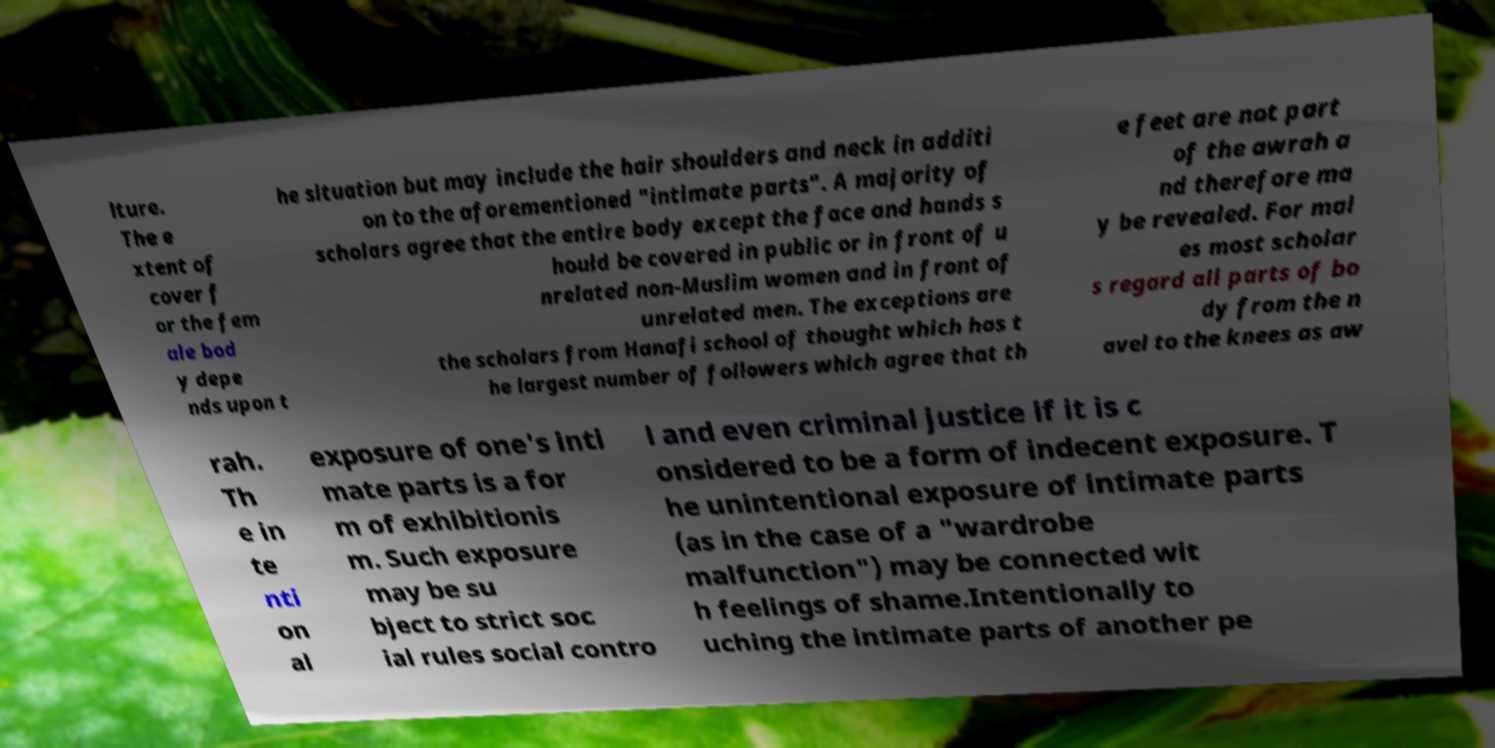Please read and relay the text visible in this image. What does it say? lture. The e xtent of cover f or the fem ale bod y depe nds upon t he situation but may include the hair shoulders and neck in additi on to the aforementioned "intimate parts". A majority of scholars agree that the entire body except the face and hands s hould be covered in public or in front of u nrelated non-Muslim women and in front of unrelated men. The exceptions are the scholars from Hanafi school of thought which has t he largest number of followers which agree that th e feet are not part of the awrah a nd therefore ma y be revealed. For mal es most scholar s regard all parts of bo dy from the n avel to the knees as aw rah. Th e in te nti on al exposure of one's inti mate parts is a for m of exhibitionis m. Such exposure may be su bject to strict soc ial rules social contro l and even criminal justice if it is c onsidered to be a form of indecent exposure. T he unintentional exposure of intimate parts (as in the case of a "wardrobe malfunction") may be connected wit h feelings of shame.Intentionally to uching the intimate parts of another pe 